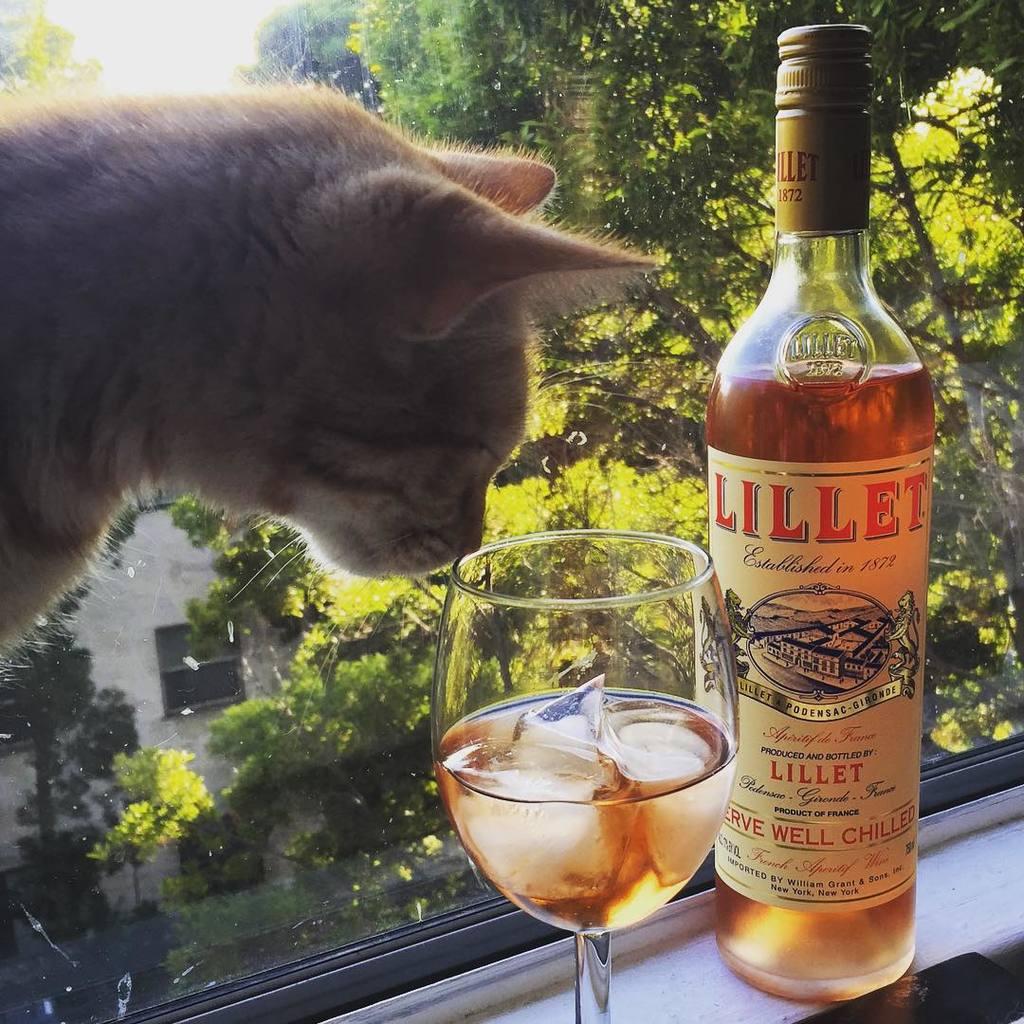When was lillet established?
Provide a short and direct response. 1872. What brand of drink is that?
Your answer should be very brief. Lillet. 